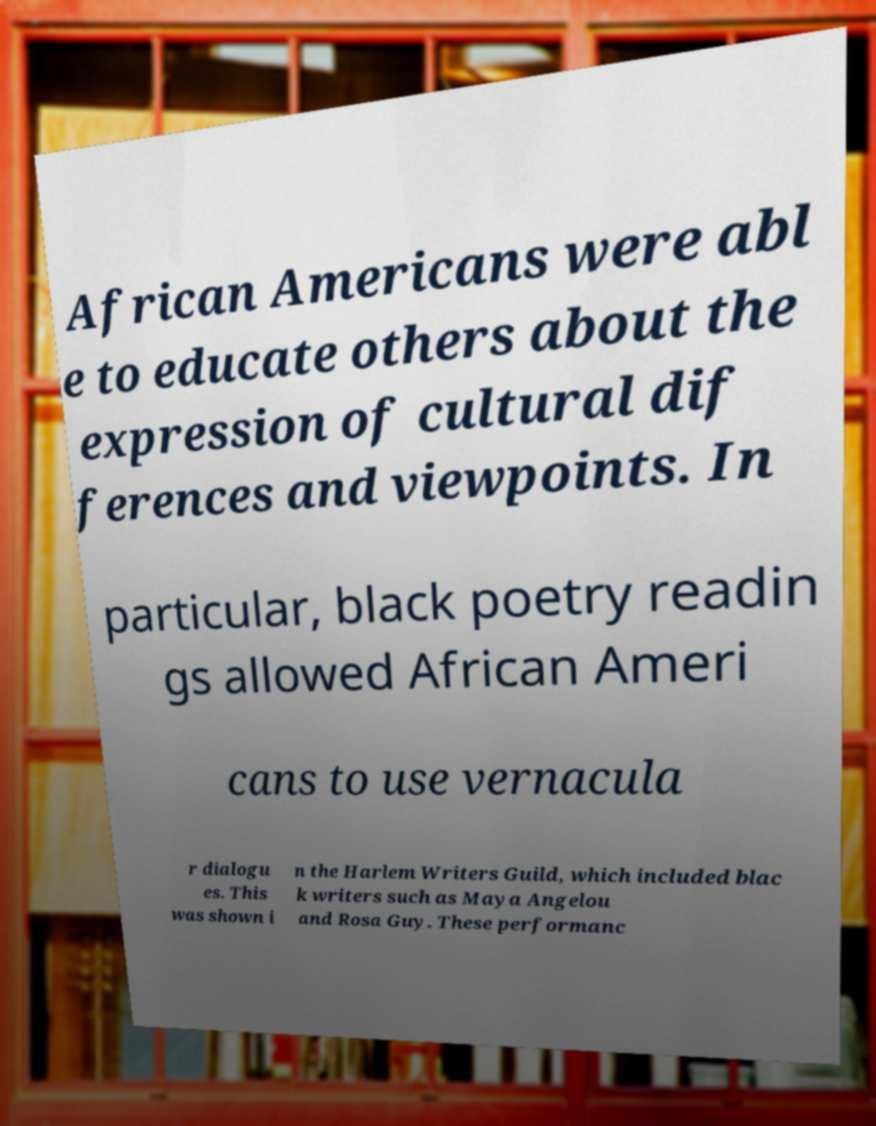For documentation purposes, I need the text within this image transcribed. Could you provide that? African Americans were abl e to educate others about the expression of cultural dif ferences and viewpoints. In particular, black poetry readin gs allowed African Ameri cans to use vernacula r dialogu es. This was shown i n the Harlem Writers Guild, which included blac k writers such as Maya Angelou and Rosa Guy. These performanc 